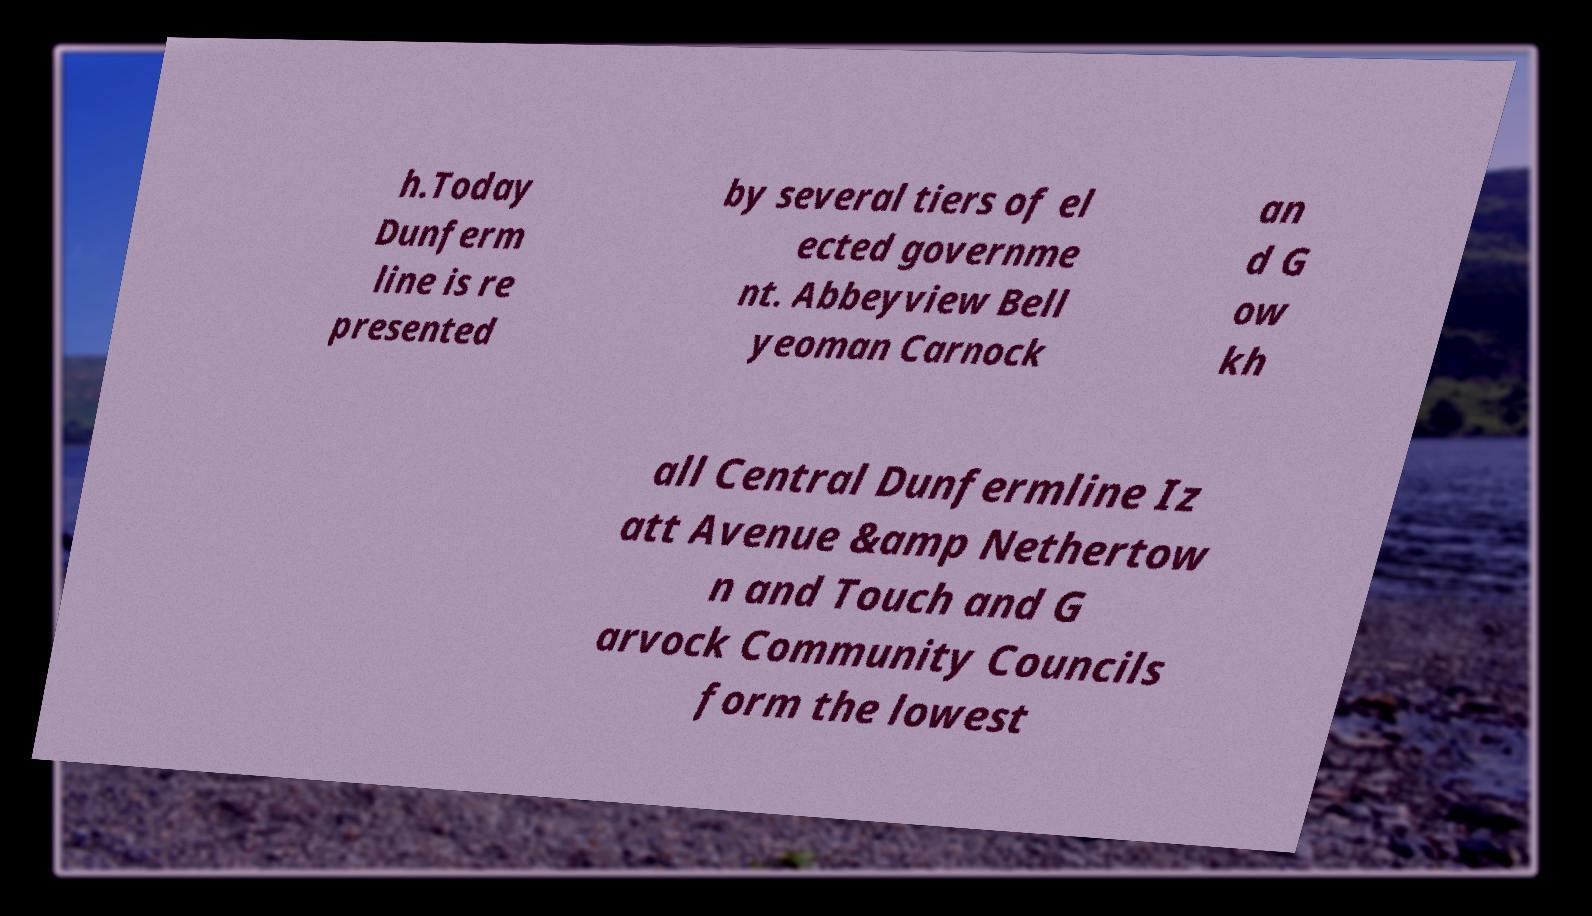Can you accurately transcribe the text from the provided image for me? h.Today Dunferm line is re presented by several tiers of el ected governme nt. Abbeyview Bell yeoman Carnock an d G ow kh all Central Dunfermline Iz att Avenue &amp Nethertow n and Touch and G arvock Community Councils form the lowest 